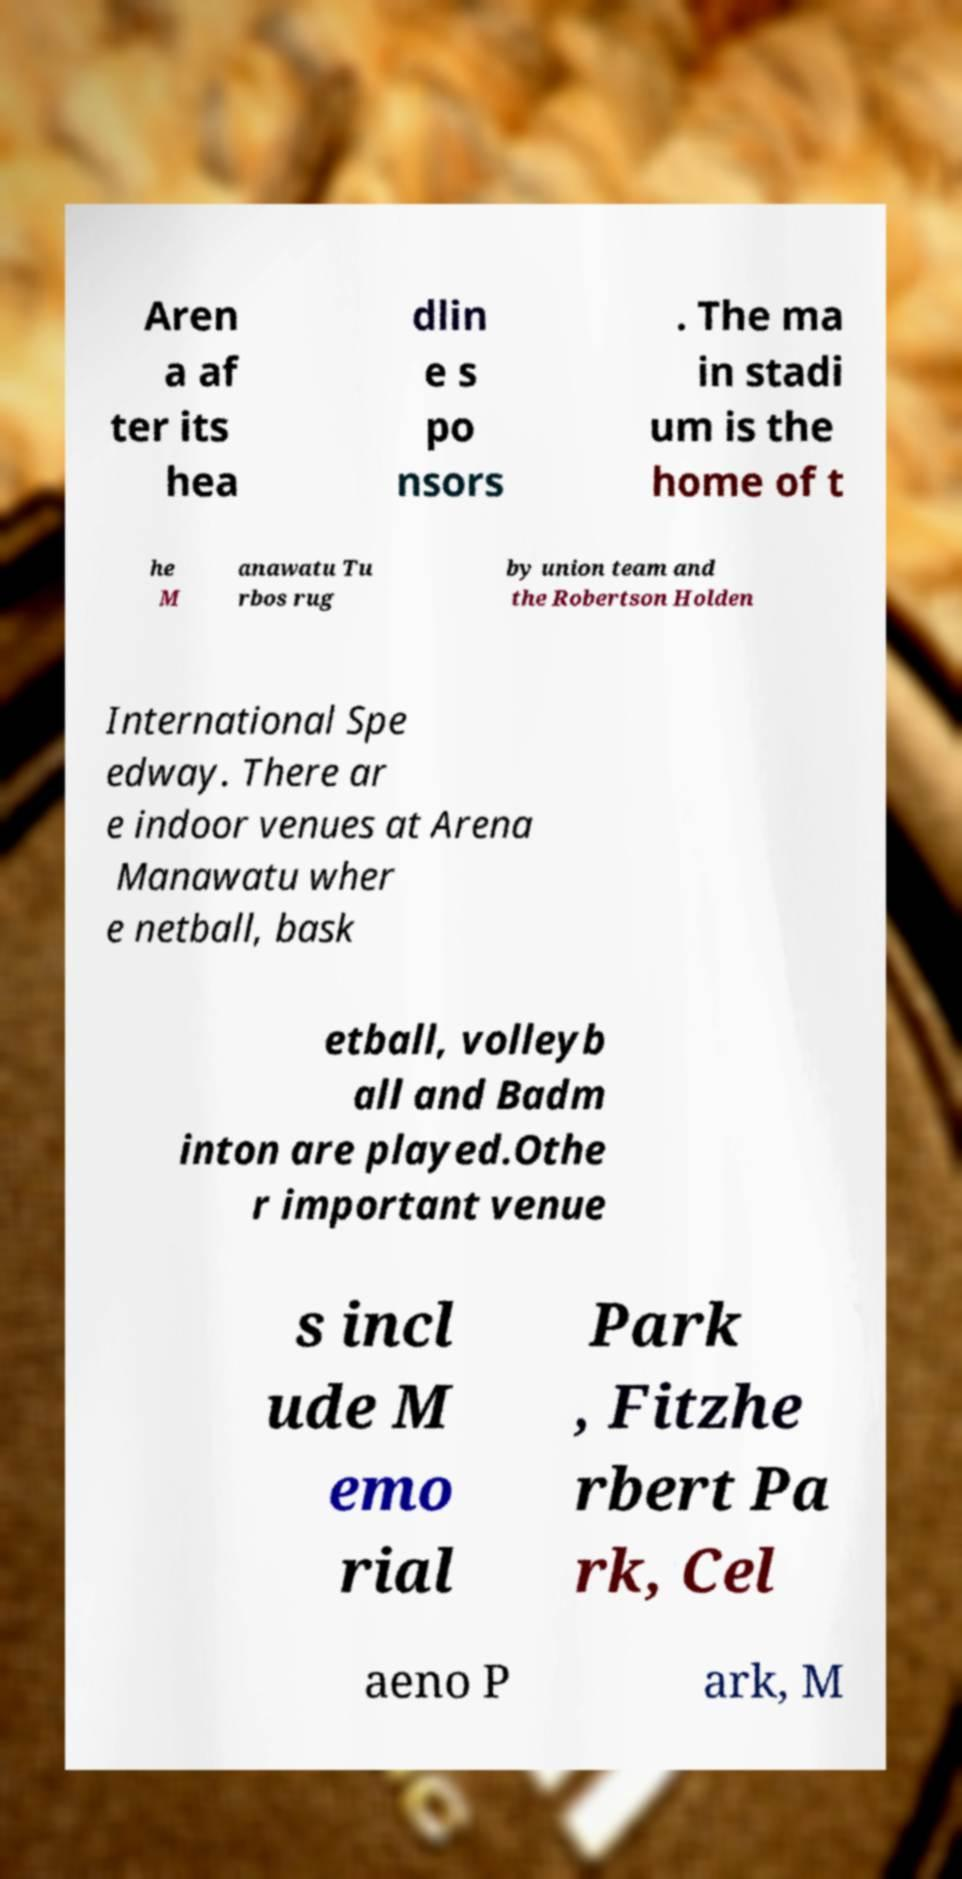Please identify and transcribe the text found in this image. Aren a af ter its hea dlin e s po nsors . The ma in stadi um is the home of t he M anawatu Tu rbos rug by union team and the Robertson Holden International Spe edway. There ar e indoor venues at Arena Manawatu wher e netball, bask etball, volleyb all and Badm inton are played.Othe r important venue s incl ude M emo rial Park , Fitzhe rbert Pa rk, Cel aeno P ark, M 